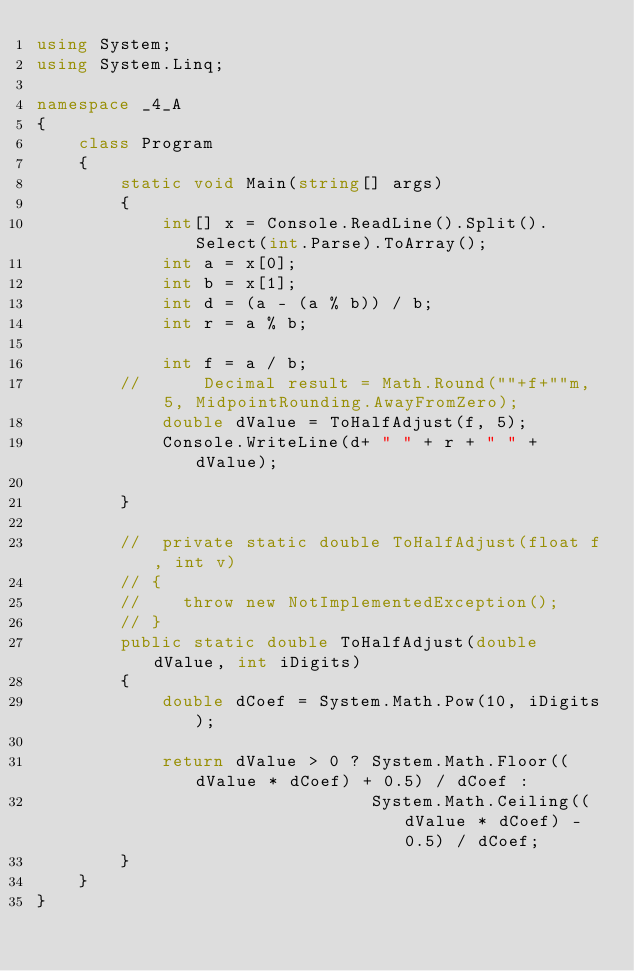Convert code to text. <code><loc_0><loc_0><loc_500><loc_500><_C#_>using System;
using System.Linq;

namespace _4_A
{
    class Program
    {
        static void Main(string[] args)
        {
            int[] x = Console.ReadLine().Split().Select(int.Parse).ToArray();
            int a = x[0];
            int b = x[1];
            int d = (a - (a % b)) / b;
            int r = a % b;
          
            int f = a / b;
        //      Decimal result = Math.Round(""+f+""m,  5, MidpointRounding.AwayFromZero);
            double dValue = ToHalfAdjust(f, 5);
            Console.WriteLine(d+ " " + r + " " + dValue);

        }

        //  private static double ToHalfAdjust(float f, int v)
        // {
        //    throw new NotImplementedException();
        // }
        public static double ToHalfAdjust(double dValue, int iDigits)
        {
            double dCoef = System.Math.Pow(10, iDigits);

            return dValue > 0 ? System.Math.Floor((dValue * dCoef) + 0.5) / dCoef :
                                System.Math.Ceiling((dValue * dCoef) - 0.5) / dCoef;
        }
    }
}</code> 